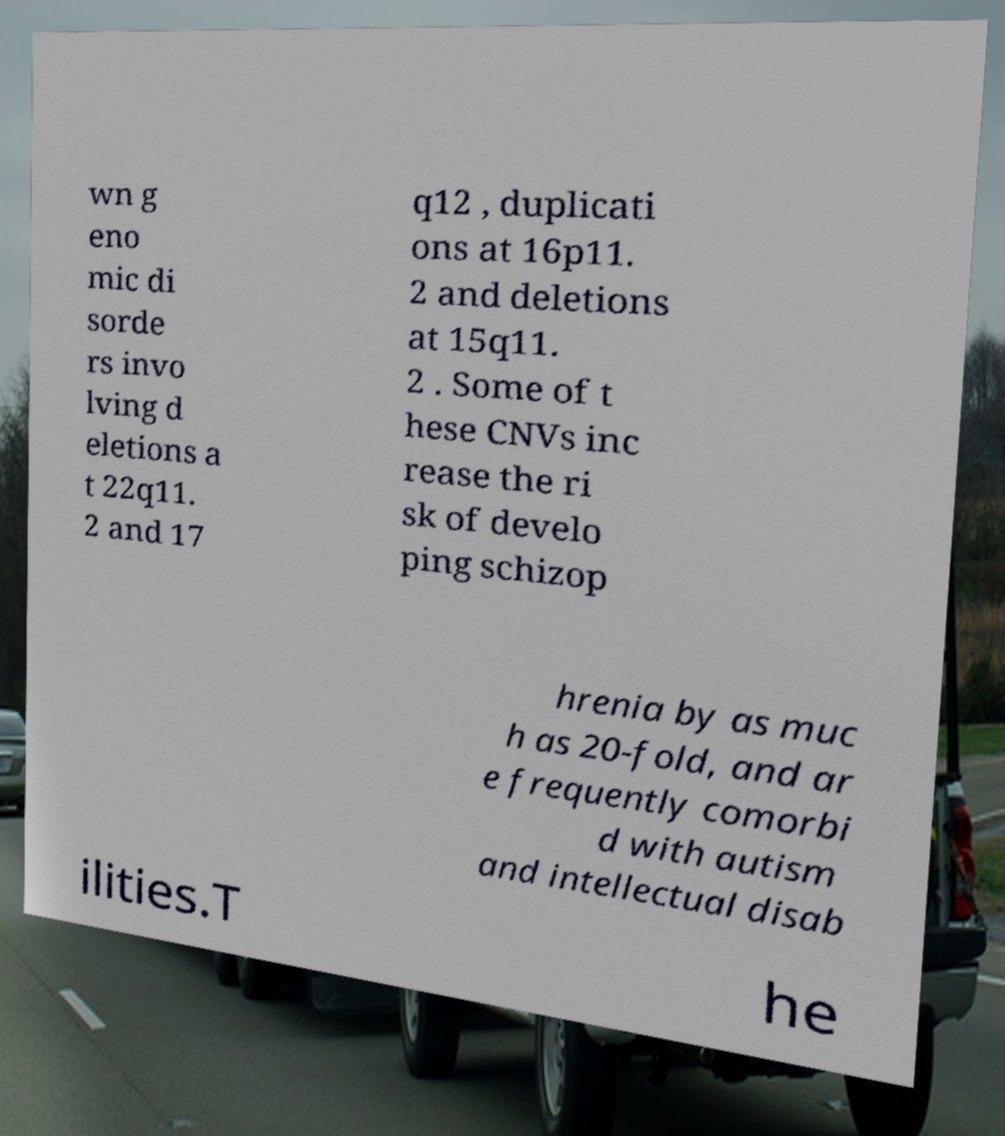Can you read and provide the text displayed in the image?This photo seems to have some interesting text. Can you extract and type it out for me? wn g eno mic di sorde rs invo lving d eletions a t 22q11. 2 and 17 q12 , duplicati ons at 16p11. 2 and deletions at 15q11. 2 . Some of t hese CNVs inc rease the ri sk of develo ping schizop hrenia by as muc h as 20-fold, and ar e frequently comorbi d with autism and intellectual disab ilities.T he 